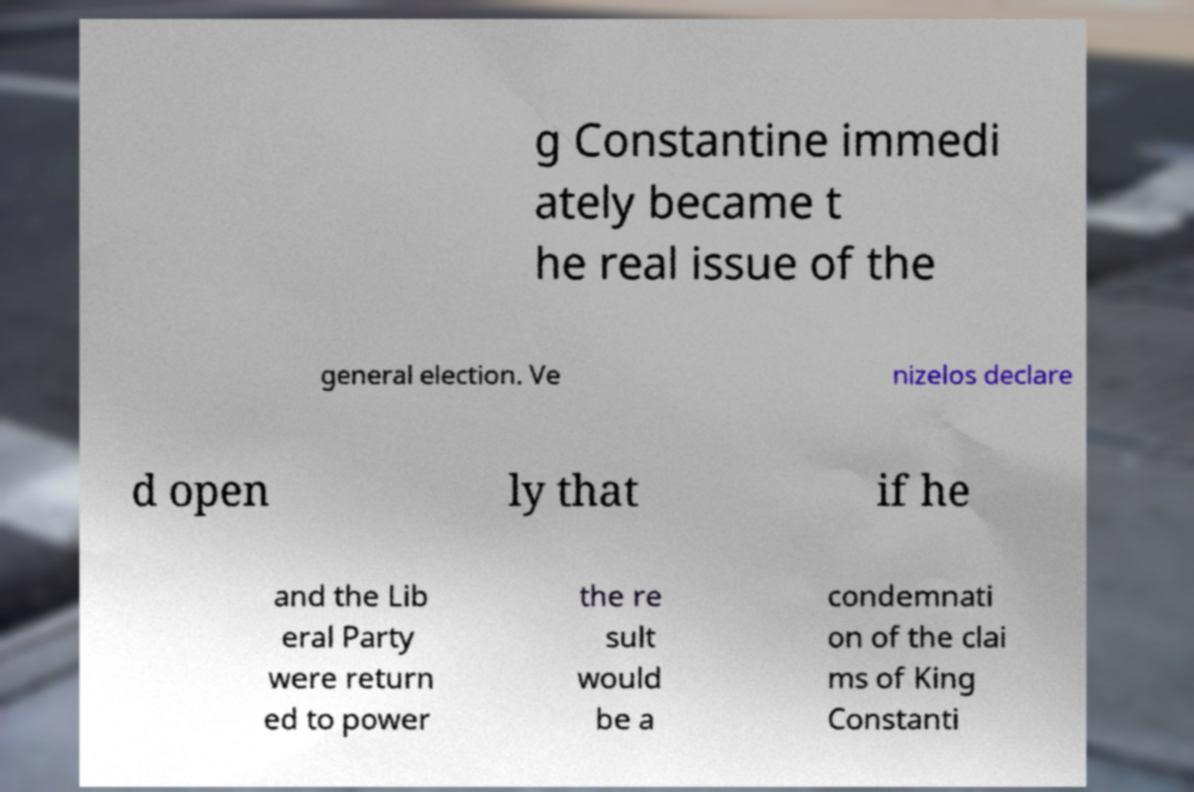For documentation purposes, I need the text within this image transcribed. Could you provide that? g Constantine immedi ately became t he real issue of the general election. Ve nizelos declare d open ly that if he and the Lib eral Party were return ed to power the re sult would be a condemnati on of the clai ms of King Constanti 